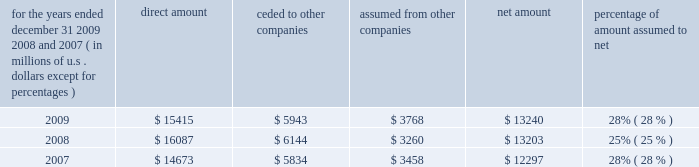S c h e d u l e i v ace limited and subsidiaries s u p p l e m e n t a l i n f o r m a t i o n c o n c e r n i n g r e i n s u r a n c e premiums earned for the years ended december 31 , 2009 , 2008 , and 2007 ( in millions of u.s .
Dollars , except for percentages ) direct amount ceded to companies assumed from other companies net amount percentage of amount assumed to .

In 2009 what was the ratio of the direct amount to the amount ceded to other companies? 
Computations: (15415 / 5943)
Answer: 2.59381. 